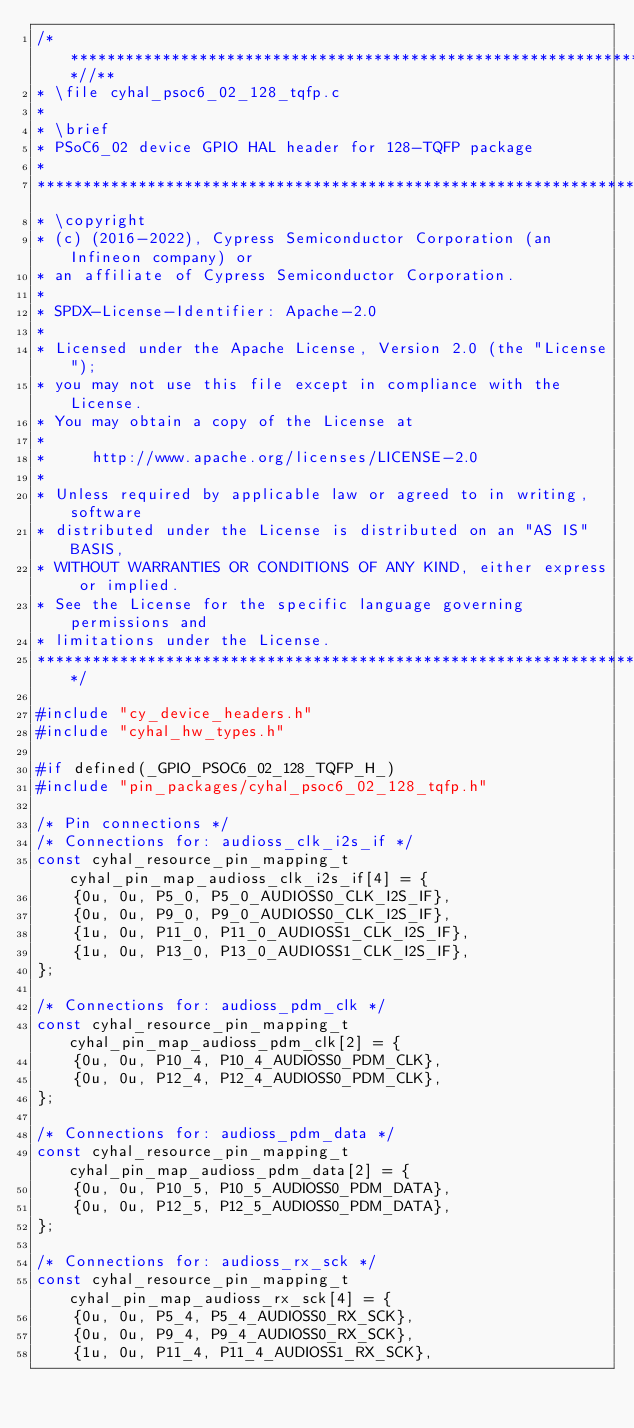<code> <loc_0><loc_0><loc_500><loc_500><_C_>/***************************************************************************//**
* \file cyhal_psoc6_02_128_tqfp.c
*
* \brief
* PSoC6_02 device GPIO HAL header for 128-TQFP package
*
********************************************************************************
* \copyright
* (c) (2016-2022), Cypress Semiconductor Corporation (an Infineon company) or
* an affiliate of Cypress Semiconductor Corporation.
*
* SPDX-License-Identifier: Apache-2.0
*
* Licensed under the Apache License, Version 2.0 (the "License");
* you may not use this file except in compliance with the License.
* You may obtain a copy of the License at
*
*     http://www.apache.org/licenses/LICENSE-2.0
*
* Unless required by applicable law or agreed to in writing, software
* distributed under the License is distributed on an "AS IS" BASIS,
* WITHOUT WARRANTIES OR CONDITIONS OF ANY KIND, either express or implied.
* See the License for the specific language governing permissions and
* limitations under the License.
*******************************************************************************/

#include "cy_device_headers.h"
#include "cyhal_hw_types.h"

#if defined(_GPIO_PSOC6_02_128_TQFP_H_)
#include "pin_packages/cyhal_psoc6_02_128_tqfp.h"

/* Pin connections */
/* Connections for: audioss_clk_i2s_if */
const cyhal_resource_pin_mapping_t cyhal_pin_map_audioss_clk_i2s_if[4] = {
    {0u, 0u, P5_0, P5_0_AUDIOSS0_CLK_I2S_IF},
    {0u, 0u, P9_0, P9_0_AUDIOSS0_CLK_I2S_IF},
    {1u, 0u, P11_0, P11_0_AUDIOSS1_CLK_I2S_IF},
    {1u, 0u, P13_0, P13_0_AUDIOSS1_CLK_I2S_IF},
};

/* Connections for: audioss_pdm_clk */
const cyhal_resource_pin_mapping_t cyhal_pin_map_audioss_pdm_clk[2] = {
    {0u, 0u, P10_4, P10_4_AUDIOSS0_PDM_CLK},
    {0u, 0u, P12_4, P12_4_AUDIOSS0_PDM_CLK},
};

/* Connections for: audioss_pdm_data */
const cyhal_resource_pin_mapping_t cyhal_pin_map_audioss_pdm_data[2] = {
    {0u, 0u, P10_5, P10_5_AUDIOSS0_PDM_DATA},
    {0u, 0u, P12_5, P12_5_AUDIOSS0_PDM_DATA},
};

/* Connections for: audioss_rx_sck */
const cyhal_resource_pin_mapping_t cyhal_pin_map_audioss_rx_sck[4] = {
    {0u, 0u, P5_4, P5_4_AUDIOSS0_RX_SCK},
    {0u, 0u, P9_4, P9_4_AUDIOSS0_RX_SCK},
    {1u, 0u, P11_4, P11_4_AUDIOSS1_RX_SCK},</code> 